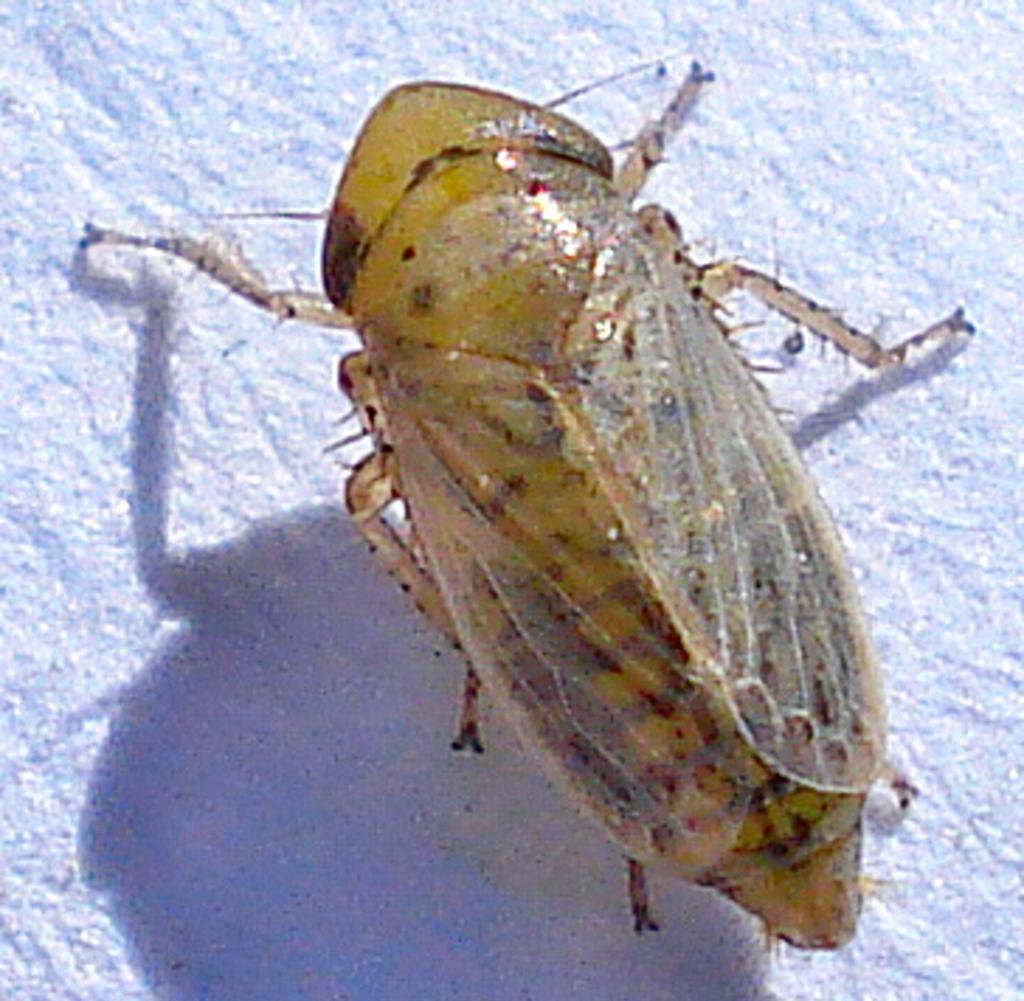How would you summarize this image in a sentence or two? In this picture we can see an insect on the surface. 